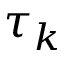<formula> <loc_0><loc_0><loc_500><loc_500>\tau _ { k }</formula> 